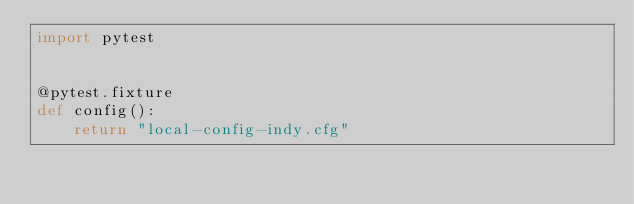Convert code to text. <code><loc_0><loc_0><loc_500><loc_500><_Python_>import pytest


@pytest.fixture
def config():
    return "local-config-indy.cfg"
</code> 